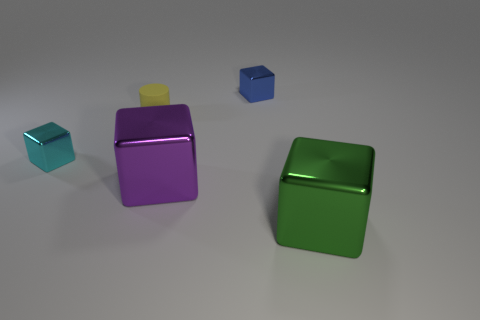Are the tiny cyan thing and the small cube behind the yellow thing made of the same material?
Your answer should be very brief. Yes. There is a green metallic thing on the right side of the tiny thing that is behind the yellow object; what is its shape?
Make the answer very short. Cube. What shape is the thing that is behind the small cyan block and right of the yellow rubber object?
Make the answer very short. Cube. How many objects are either green objects or metal blocks right of the tiny cyan object?
Offer a very short reply. 3. There is a blue object that is the same shape as the big green object; what is it made of?
Make the answer very short. Metal. Are there any other things that are made of the same material as the tiny blue block?
Make the answer very short. Yes. What is the thing that is both right of the large purple block and in front of the tiny blue object made of?
Your response must be concise. Metal. How many cyan metallic things have the same shape as the small rubber object?
Your response must be concise. 0. What color is the shiny cube that is in front of the large metallic cube that is behind the large green object?
Your answer should be very brief. Green. Is the number of small cyan blocks that are on the right side of the small cyan cube the same as the number of green metallic cubes?
Your answer should be very brief. No. 